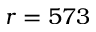<formula> <loc_0><loc_0><loc_500><loc_500>r = 5 7 3</formula> 